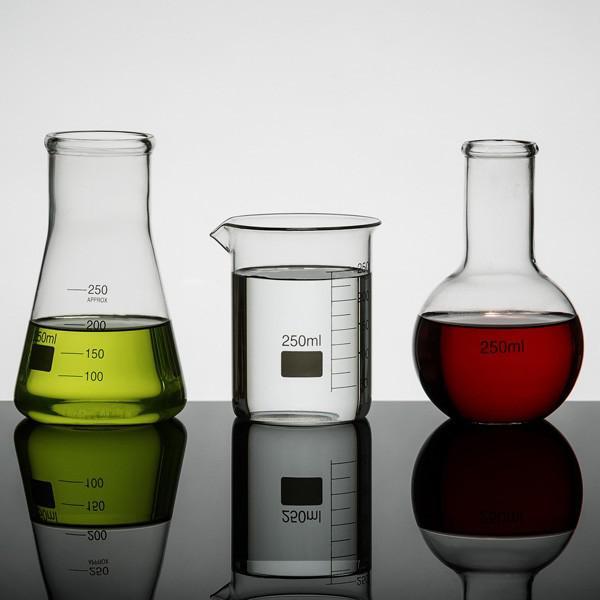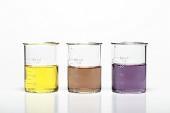The first image is the image on the left, the second image is the image on the right. For the images displayed, is the sentence "All glass vessels contain a non-clear liquid, and one set of beakers shares the same shape." factually correct? Answer yes or no. No. The first image is the image on the left, the second image is the image on the right. For the images shown, is this caption "The right image contains exactly four flasks." true? Answer yes or no. No. 